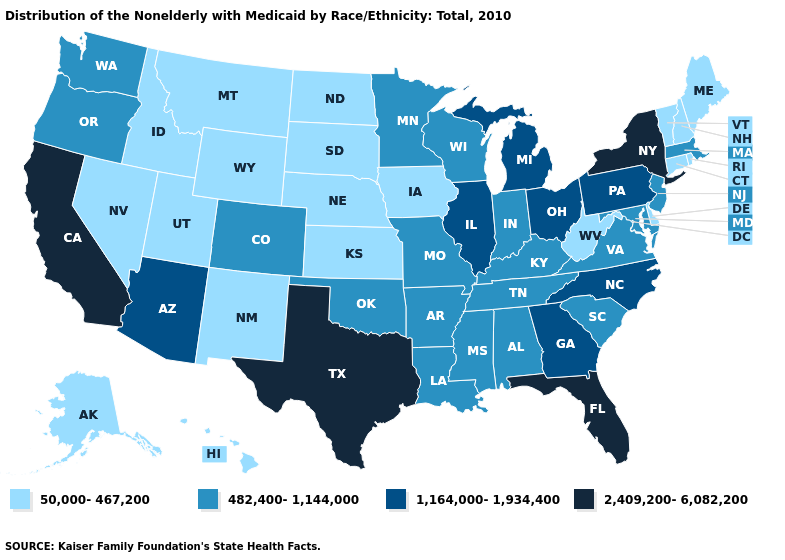Name the states that have a value in the range 1,164,000-1,934,400?
Give a very brief answer. Arizona, Georgia, Illinois, Michigan, North Carolina, Ohio, Pennsylvania. Is the legend a continuous bar?
Be succinct. No. Name the states that have a value in the range 1,164,000-1,934,400?
Give a very brief answer. Arizona, Georgia, Illinois, Michigan, North Carolina, Ohio, Pennsylvania. What is the highest value in states that border North Carolina?
Quick response, please. 1,164,000-1,934,400. Name the states that have a value in the range 1,164,000-1,934,400?
Give a very brief answer. Arizona, Georgia, Illinois, Michigan, North Carolina, Ohio, Pennsylvania. What is the value of New Hampshire?
Keep it brief. 50,000-467,200. Name the states that have a value in the range 2,409,200-6,082,200?
Give a very brief answer. California, Florida, New York, Texas. Name the states that have a value in the range 50,000-467,200?
Quick response, please. Alaska, Connecticut, Delaware, Hawaii, Idaho, Iowa, Kansas, Maine, Montana, Nebraska, Nevada, New Hampshire, New Mexico, North Dakota, Rhode Island, South Dakota, Utah, Vermont, West Virginia, Wyoming. Name the states that have a value in the range 1,164,000-1,934,400?
Answer briefly. Arizona, Georgia, Illinois, Michigan, North Carolina, Ohio, Pennsylvania. What is the value of Nevada?
Quick response, please. 50,000-467,200. Name the states that have a value in the range 50,000-467,200?
Answer briefly. Alaska, Connecticut, Delaware, Hawaii, Idaho, Iowa, Kansas, Maine, Montana, Nebraska, Nevada, New Hampshire, New Mexico, North Dakota, Rhode Island, South Dakota, Utah, Vermont, West Virginia, Wyoming. Does the map have missing data?
Give a very brief answer. No. Does New York have the highest value in the Northeast?
Give a very brief answer. Yes. Which states have the highest value in the USA?
Answer briefly. California, Florida, New York, Texas. 